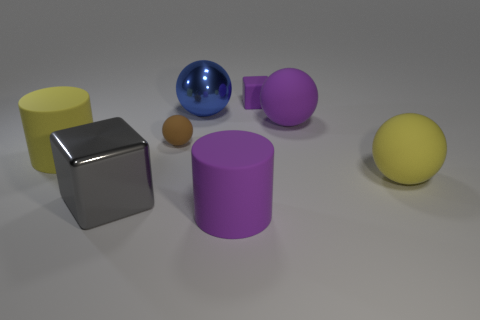Add 1 tiny objects. How many objects exist? 9 Subtract all cubes. How many objects are left? 6 Add 8 metallic blocks. How many metallic blocks exist? 9 Subtract 0 green cubes. How many objects are left? 8 Subtract all big cyan cylinders. Subtract all blue metallic objects. How many objects are left? 7 Add 1 purple rubber objects. How many purple rubber objects are left? 4 